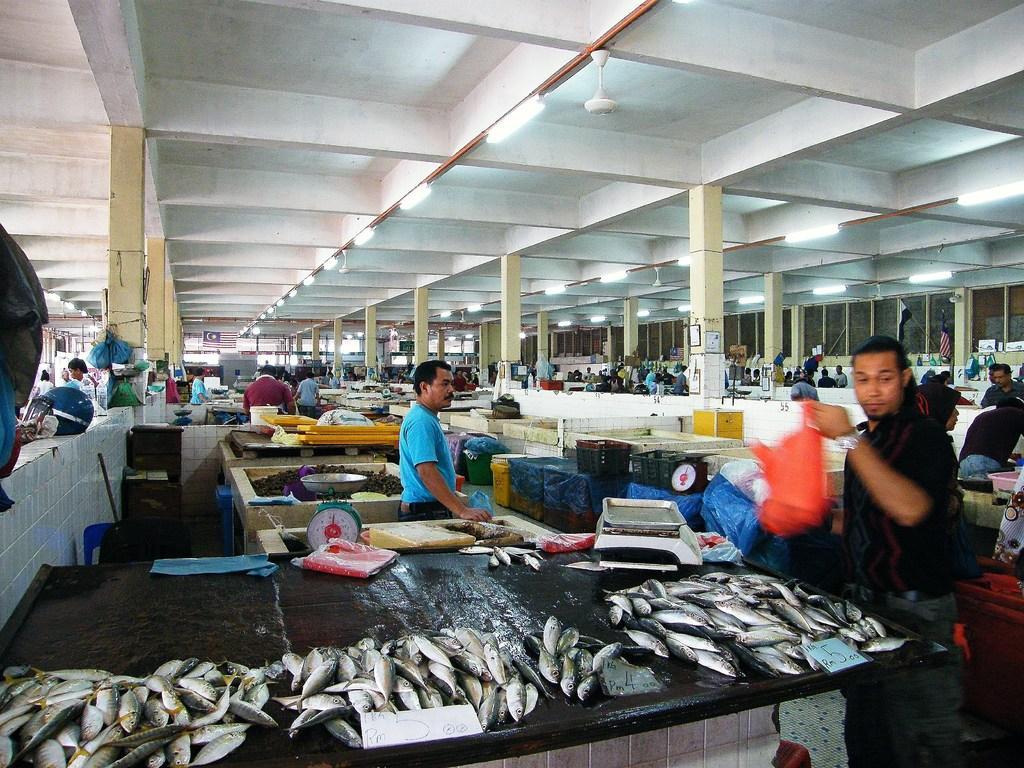Could you give a brief overview of what you see in this image? In this image we can see fishes, countertops, weighing machine, persons, pillars, tube lights, and fans. 